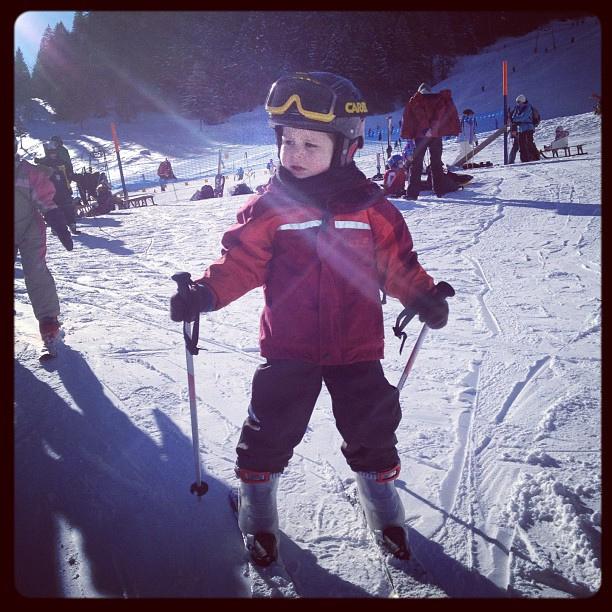Is the child wearing skis?
Write a very short answer. Yes. What color coat is the child wearing?
Answer briefly. Red. What sport is this child performing?
Be succinct. Skiing. 